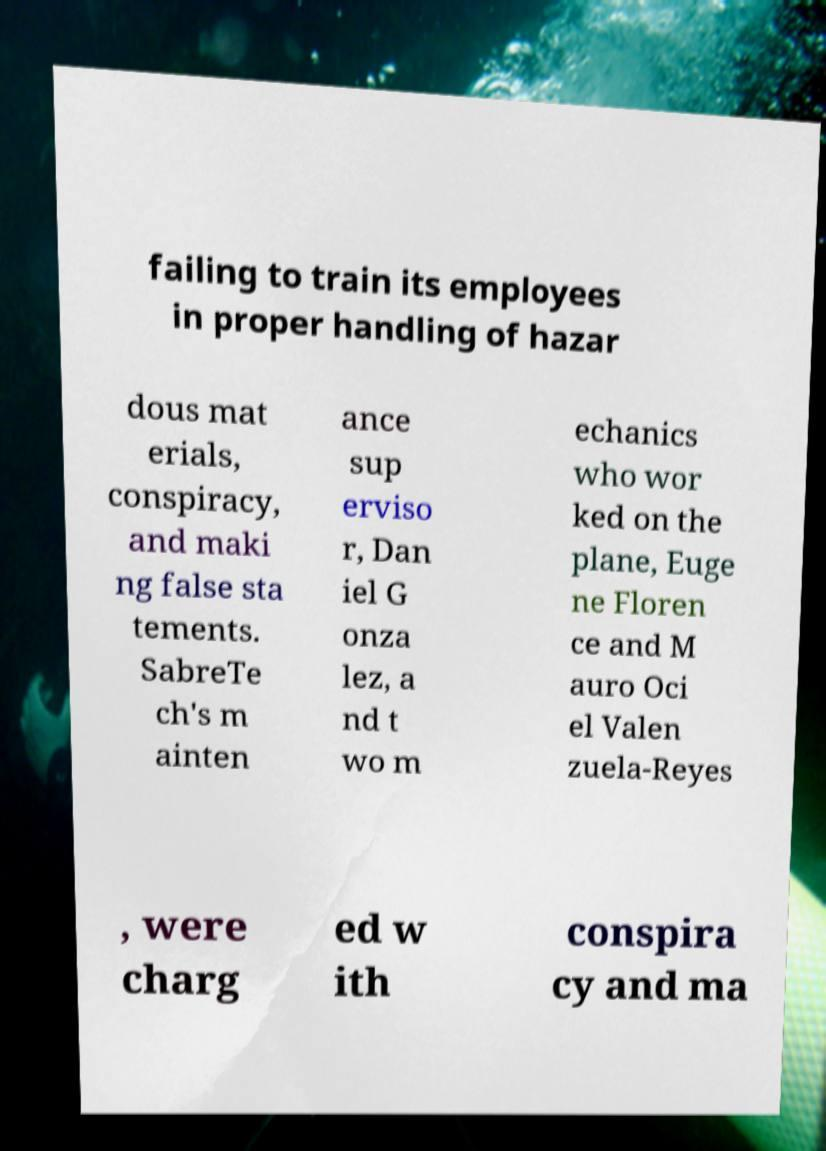Can you accurately transcribe the text from the provided image for me? failing to train its employees in proper handling of hazar dous mat erials, conspiracy, and maki ng false sta tements. SabreTe ch's m ainten ance sup erviso r, Dan iel G onza lez, a nd t wo m echanics who wor ked on the plane, Euge ne Floren ce and M auro Oci el Valen zuela-Reyes , were charg ed w ith conspira cy and ma 